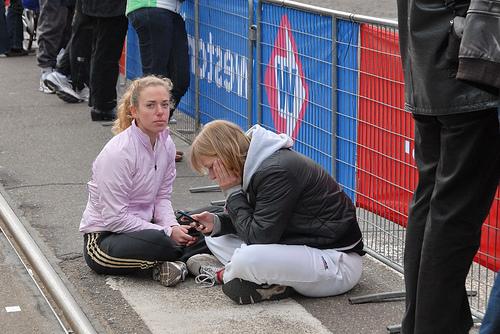Are both girls wearing sweatpants?
Keep it brief. Yes. What direction is the arrow pointing?
Concise answer only. Right. What is the woman on the right holding?
Give a very brief answer. Phone. Where are the woman in the picture?
Quick response, please. Sidewalk. Why are they sitting on the ground?
Short answer required. Waiting. 